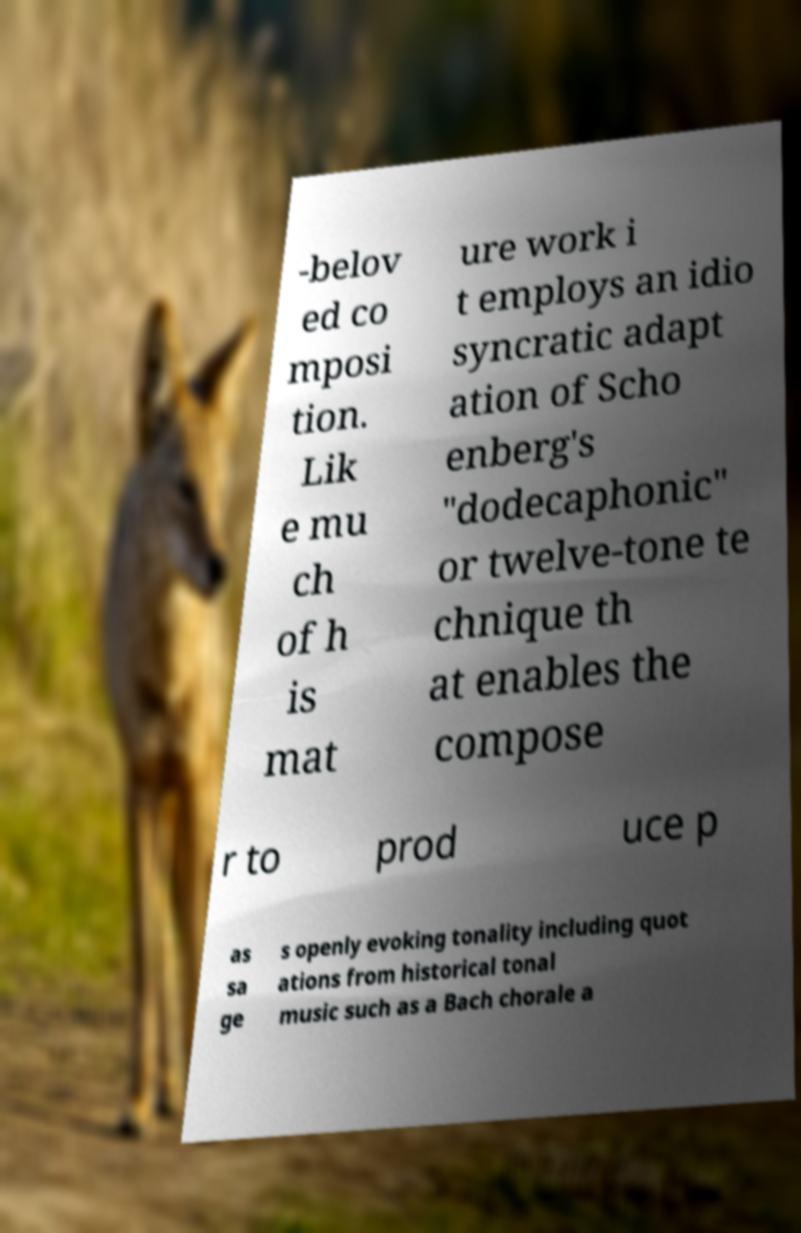There's text embedded in this image that I need extracted. Can you transcribe it verbatim? -belov ed co mposi tion. Lik e mu ch of h is mat ure work i t employs an idio syncratic adapt ation of Scho enberg's "dodecaphonic" or twelve-tone te chnique th at enables the compose r to prod uce p as sa ge s openly evoking tonality including quot ations from historical tonal music such as a Bach chorale a 